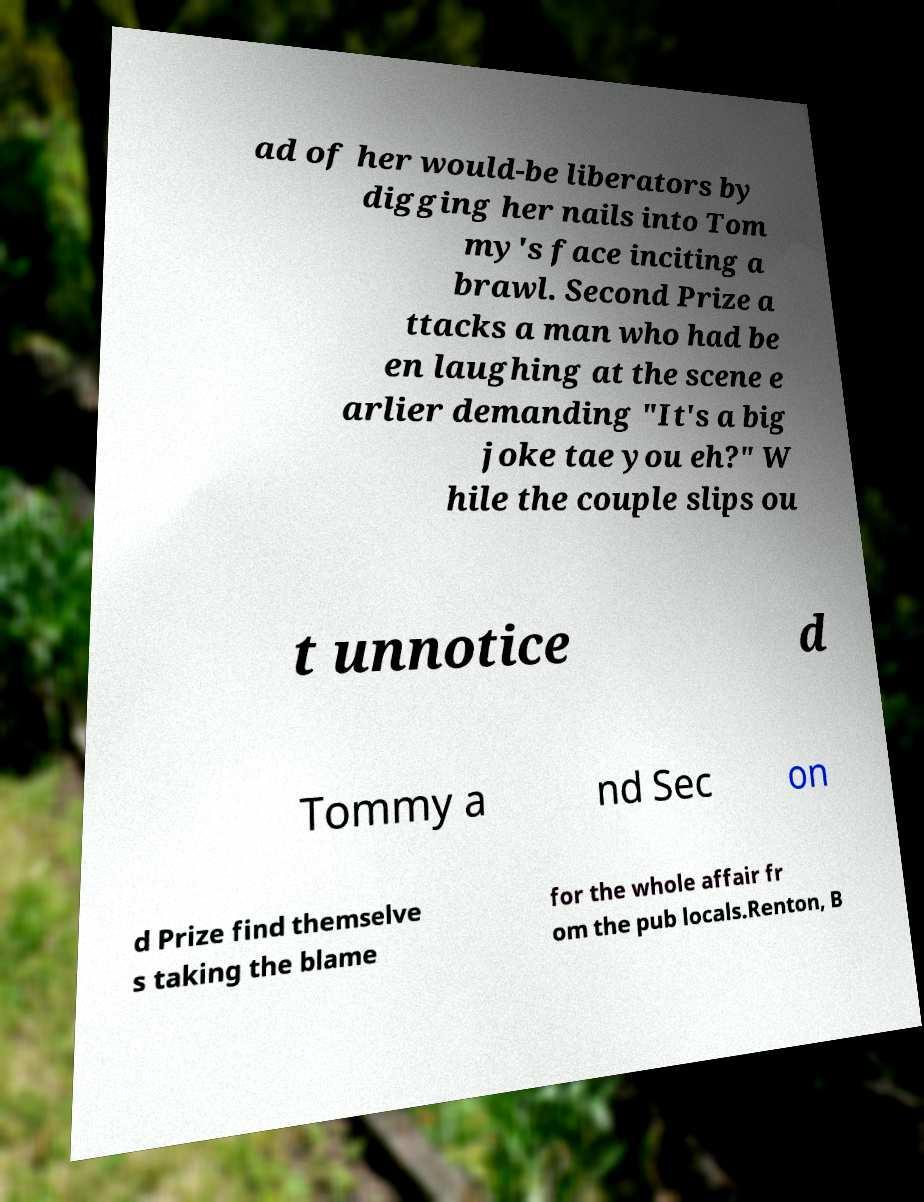Please identify and transcribe the text found in this image. ad of her would-be liberators by digging her nails into Tom my's face inciting a brawl. Second Prize a ttacks a man who had be en laughing at the scene e arlier demanding "It's a big joke tae you eh?" W hile the couple slips ou t unnotice d Tommy a nd Sec on d Prize find themselve s taking the blame for the whole affair fr om the pub locals.Renton, B 